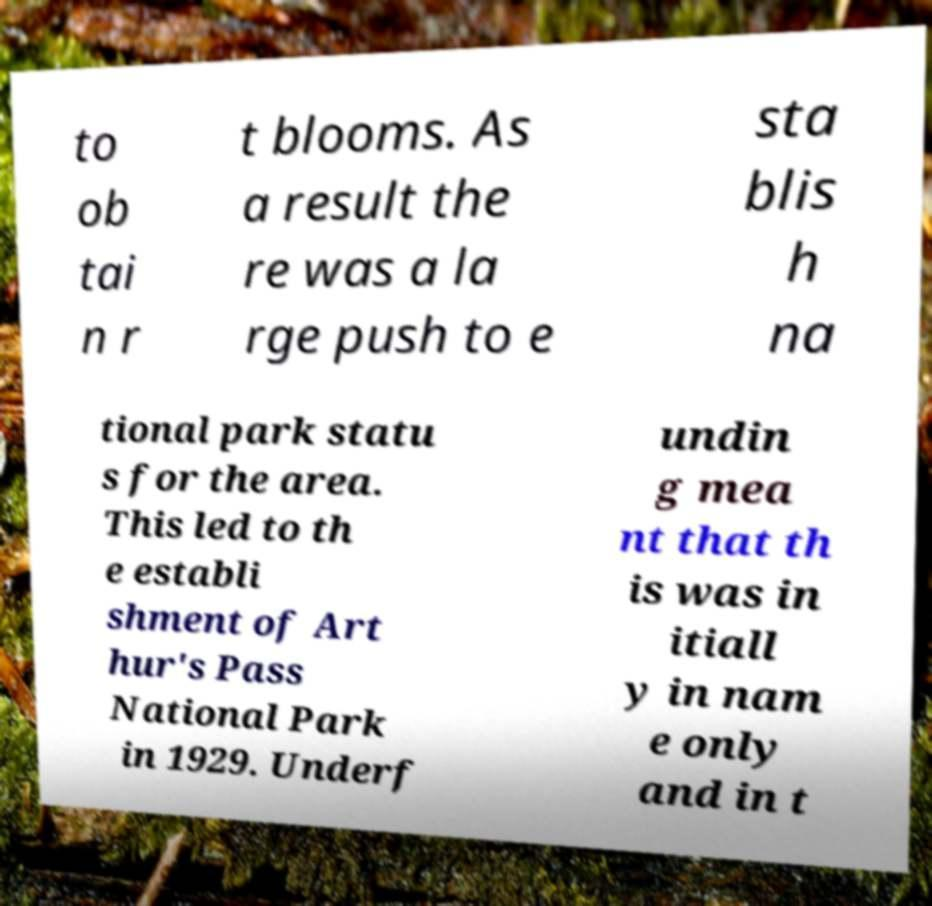I need the written content from this picture converted into text. Can you do that? to ob tai n r t blooms. As a result the re was a la rge push to e sta blis h na tional park statu s for the area. This led to th e establi shment of Art hur's Pass National Park in 1929. Underf undin g mea nt that th is was in itiall y in nam e only and in t 